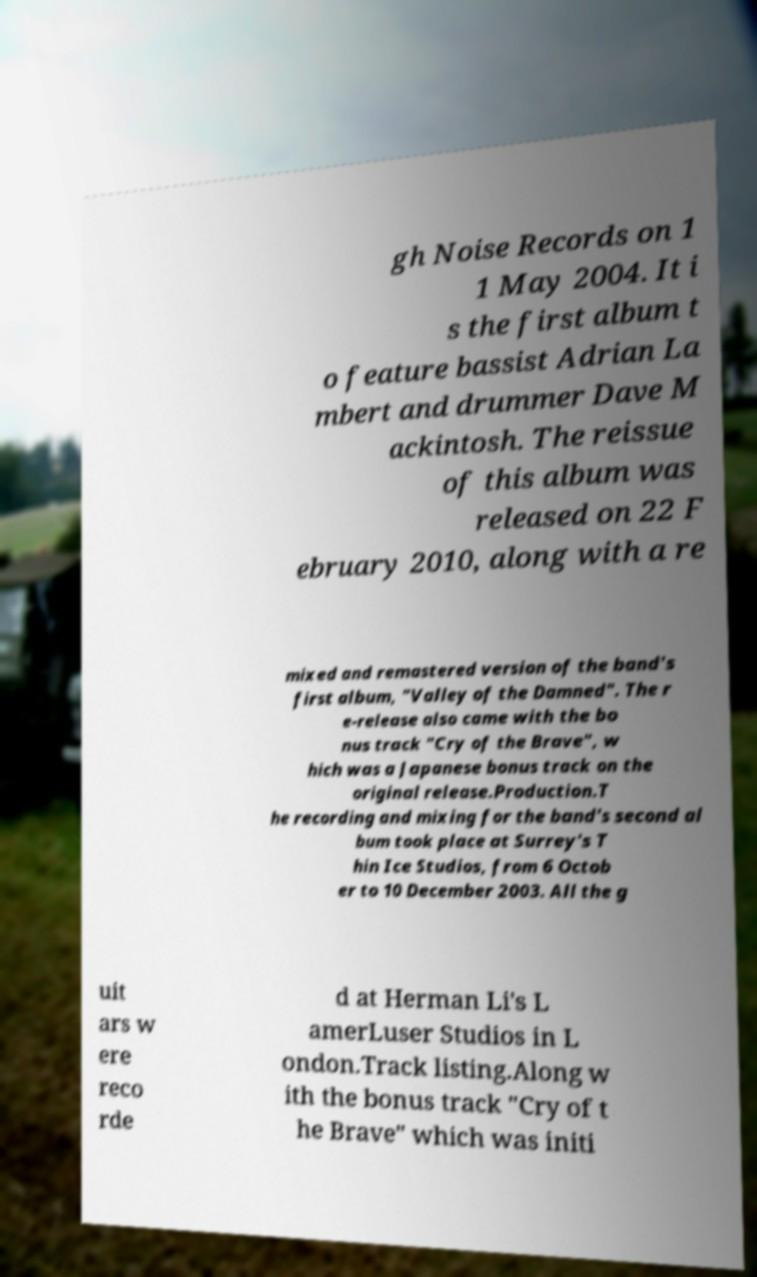Could you assist in decoding the text presented in this image and type it out clearly? gh Noise Records on 1 1 May 2004. It i s the first album t o feature bassist Adrian La mbert and drummer Dave M ackintosh. The reissue of this album was released on 22 F ebruary 2010, along with a re mixed and remastered version of the band's first album, "Valley of the Damned". The r e-release also came with the bo nus track "Cry of the Brave", w hich was a Japanese bonus track on the original release.Production.T he recording and mixing for the band's second al bum took place at Surrey's T hin Ice Studios, from 6 Octob er to 10 December 2003. All the g uit ars w ere reco rde d at Herman Li's L amerLuser Studios in L ondon.Track listing.Along w ith the bonus track "Cry of t he Brave" which was initi 